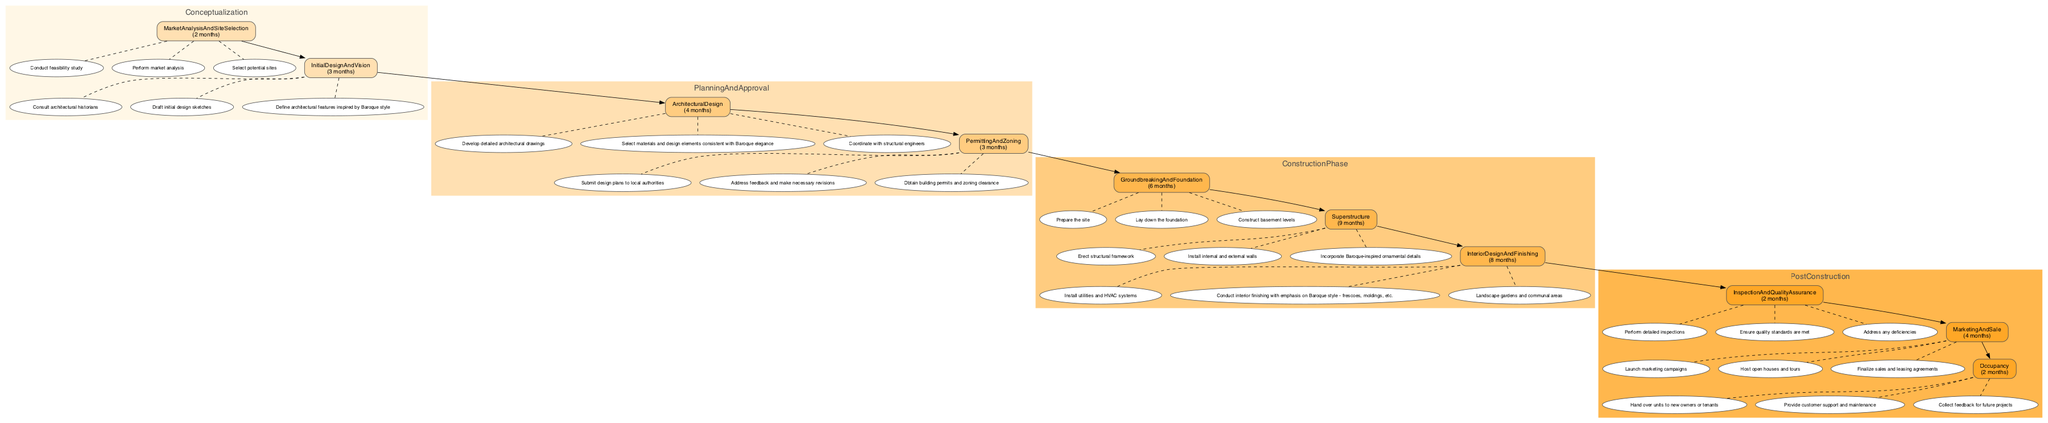What is the total duration for the Planning and Approval phase? The Planning and Approval phase consists of two stages: Architectural Design (4 months) and Permitting and Zoning (3 months). Adding these durations together yields 4 + 3 = 7 months.
Answer: 7 months Which stage has the shortest timeline in the conceptualization phase? In the conceptualization phase, there are two stages: Market Analysis and Site Selection (2 months) and Initial Design and Vision (3 months). The shortest is Market Analysis and Site Selection, which takes 2 months.
Answer: Market Analysis and Site Selection What are the activities included in the Superstructure stage? The Superstructure stage includes the following activities: Erect structural framework, Install internal and external walls, and Incorporate Baroque-inspired ornamental details.
Answer: Erect structural framework, Install internal and external walls, Incorporate Baroque-inspired ornamental details How many activities are listed under Interior Design and Finishing? The Interior Design and Finishing stage has three activities: Install utilities and HVAC systems, Conduct interior finishing with emphasis on Baroque style - frescoes, moldings, etc., and Landscape gardens and communal areas. Thus, there are three activities in total.
Answer: 3 What phase follows the construction phase? The diagram indicates that the Post Construction phase directly follows the Construction Phase, which includes stages such as Inspection and Quality Assurance, Marketing and Sale, and Occupancy.
Answer: Post Construction What is the total duration of the Inspection and Quality Assurance stage? The timeline for the Inspection and Quality Assurance stage is specified in the diagram as 2 months, which directly answers this question.
Answer: 2 months Which activities are included in the Groundbreaking and Foundation stage? The Groundbreaking and Foundation stage includes three activities: Prepare the site, Lay down the foundation, and Construct basement levels. These activities focus on the initial stages of construction.
Answer: Prepare the site, Lay down the foundation, Construct basement levels How is the relationship between Architectural Design and Permitting and Zoning established? Architectural Design leads to Permitting and Zoning in the Planning and Approval phase. This relationship demonstrates that after the architectural design is completed, it is submitted for permitting and zoning clearance.
Answer: Architectural Design to Permitting and Zoning In which stage would you find activities related to marketing? Activities related to marketing are found in the Marketing and Sale stage, which is part of the Post Construction phase. This stage focuses on launching marketing campaigns and finalizing sales agreements.
Answer: Marketing and Sale 